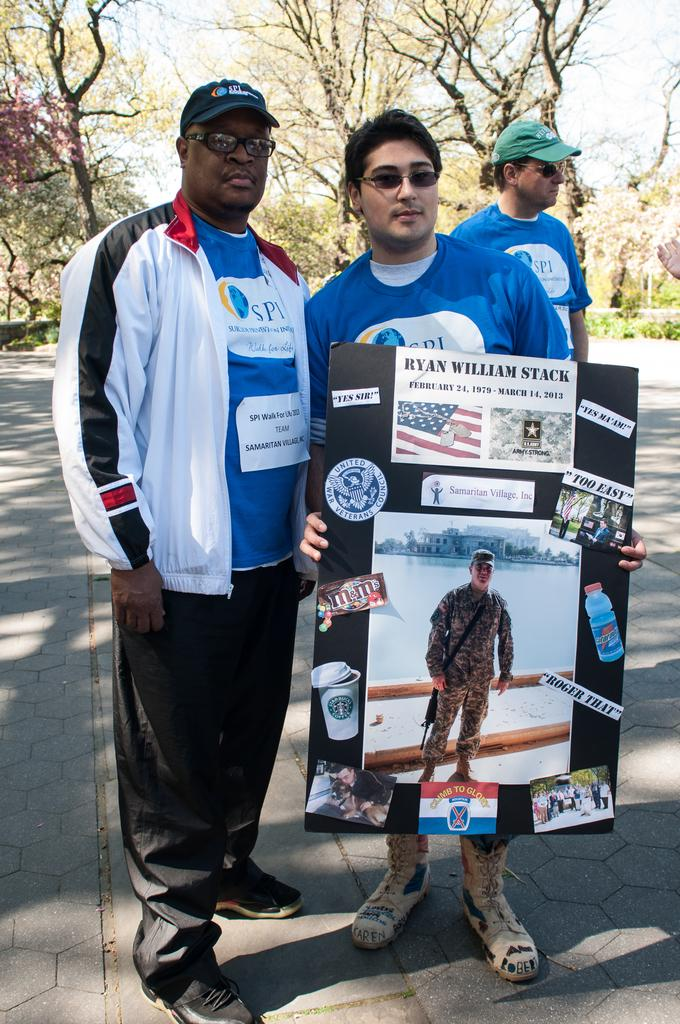How many people are standing on the road in the image? There are three persons standing on the road in the image. What is one of the persons holding in their hands? One of the persons is holding a hoarding with their hands. What can be seen in the background of the image? There are plants, trees, and the sky visible in the background of the image. What type of box is being used to store the manager's death in the image? There is no box or mention of a manager's death in the image; it features three persons standing on the road and a person holding a hoarding. 